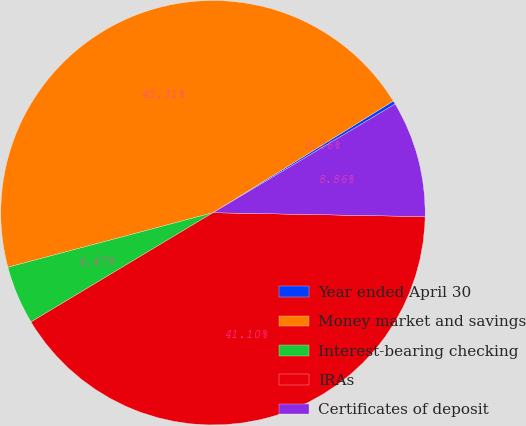<chart> <loc_0><loc_0><loc_500><loc_500><pie_chart><fcel>Year ended April 30<fcel>Money market and savings<fcel>Interest-bearing checking<fcel>IRAs<fcel>Certificates of deposit<nl><fcel>0.26%<fcel>45.31%<fcel>4.47%<fcel>41.1%<fcel>8.86%<nl></chart> 